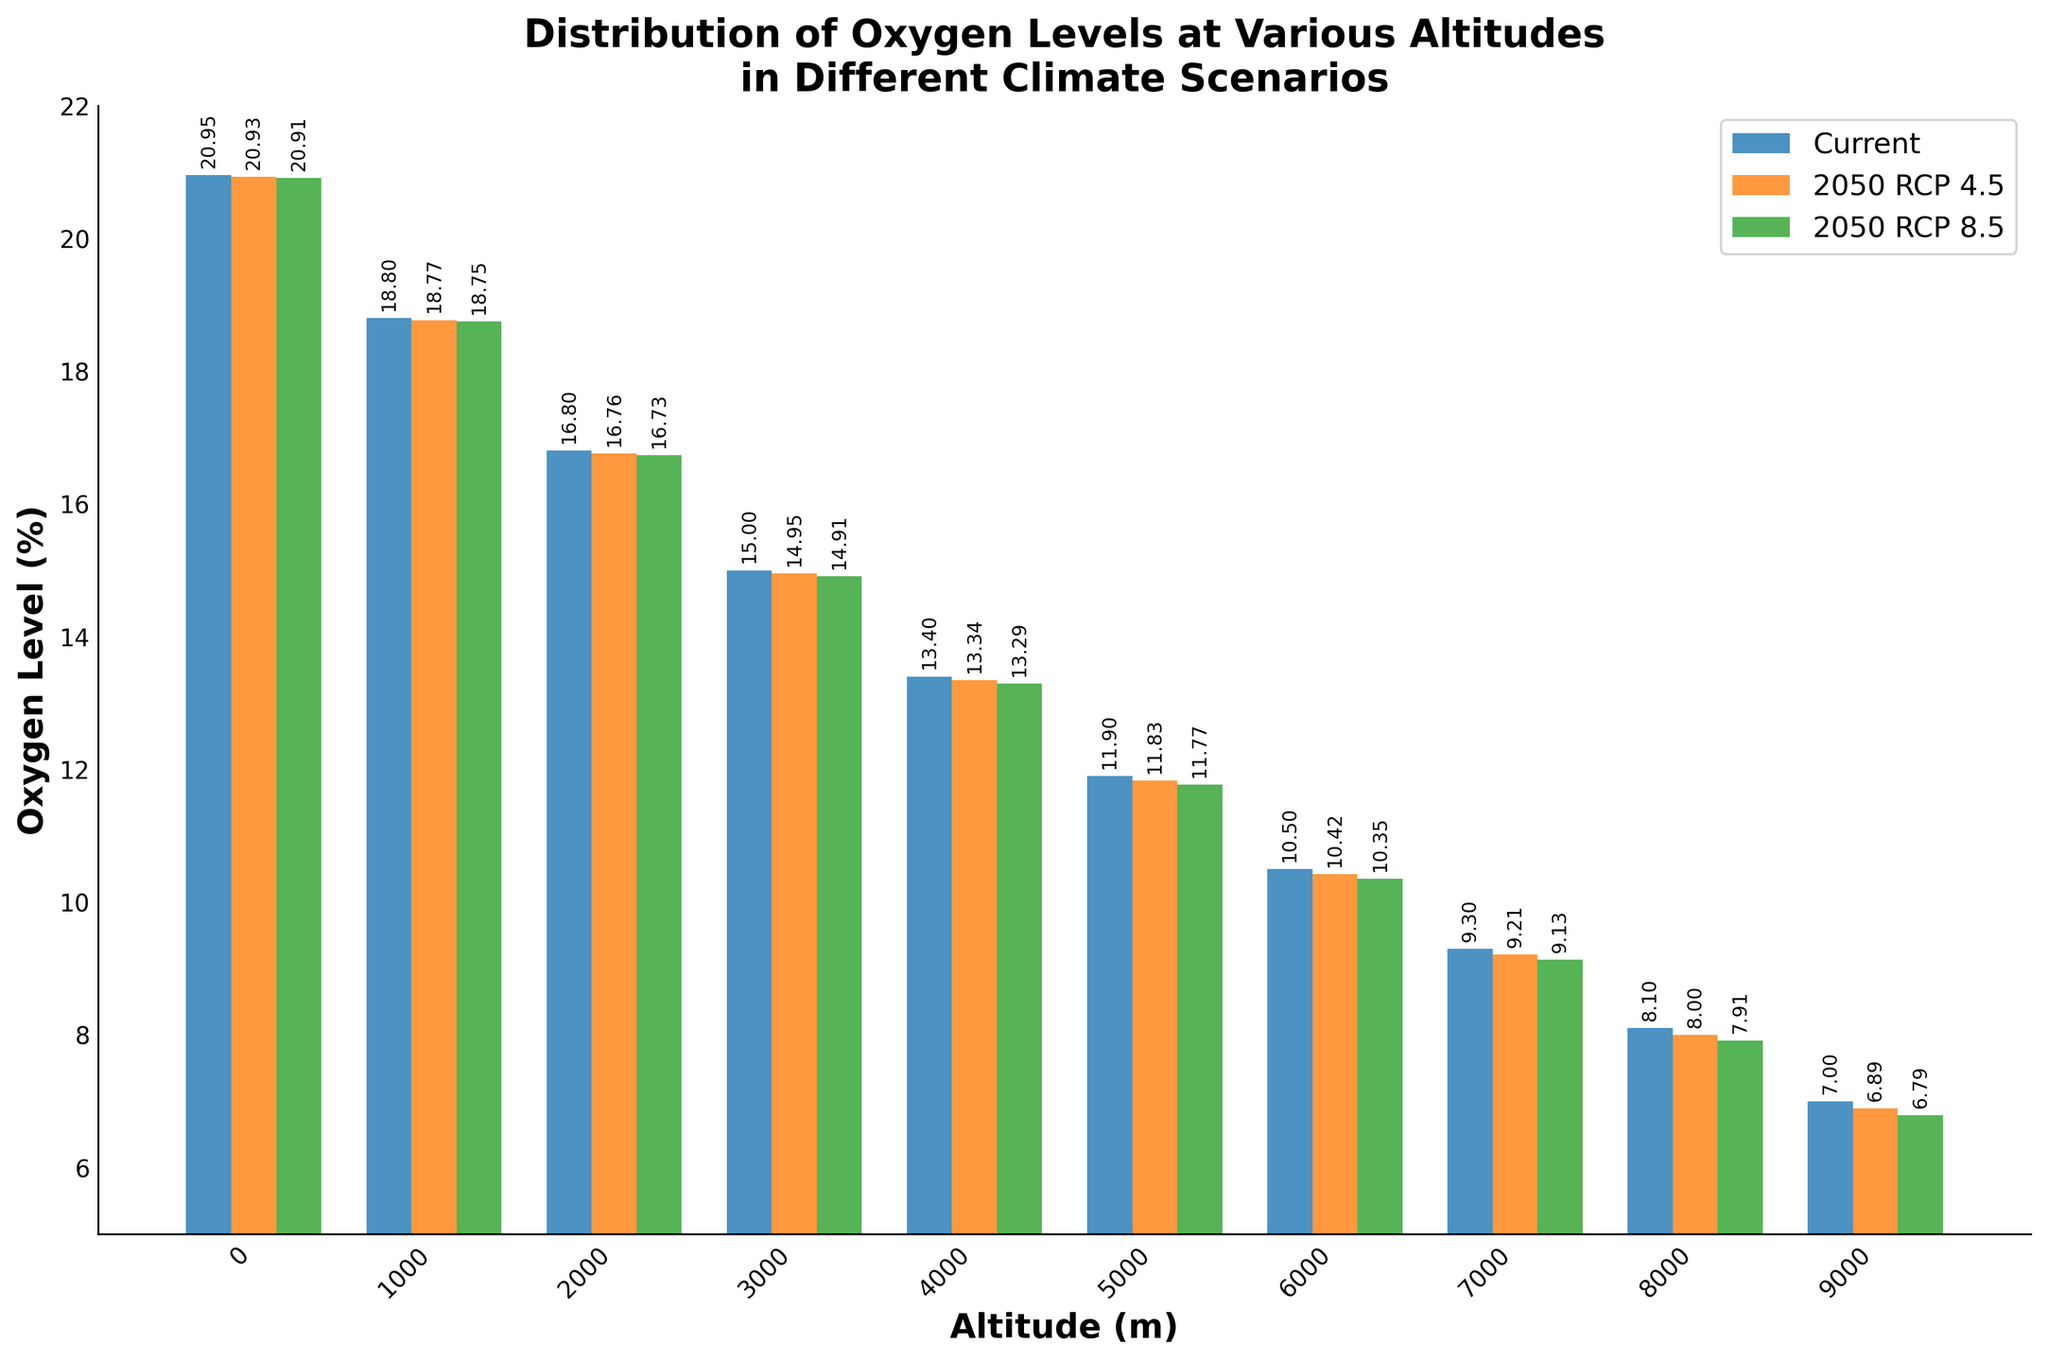What is the oxygen level at 2000 meters altitude in the current scenario? Locate the bar corresponding to 2000 meters (fourth bar in each group). The height of the blue bar representing the current scenario reads 16.8%.
Answer: 16.8% Which altitude shows the largest decrease in oxygen levels from the current scenario to the 2050 RCP 8.5 scenario? Follow each group of three bars from 0 to 9000 meters and note the difference between the height of the blue and green bars. The largest decrease is observed at 9000 meters, where the oxygen level decreases from 7.0% to 6.79%, a difference of 0.21%.
Answer: 9000 meters Comparing all altitudes, which altitude has the smallest oxygen level in the 2050 RCP 4.5 scenario? Examine the heights of the orange bars (2050 RCP 4.5 scenario) for each altitude. The smallest oxygen level is at 9000 meters, reading 6.89%.
Answer: 9000 meters Considering all scenarios and altitudes, what is the highest oxygen level recorded, and at which altitude? Observe all the bars and note the highest bar. The tallest bar is the blue one in the current scenario at 0 meters altitude with an oxygen level of 20.95%.
Answer: 20.95%, 0 meters What is the cumulative reduction in oxygen level from the current scenario to the 2050 RCP 4.5 scenario across all altitudes? Calculate the difference between current and 2050 RCP 4.5 oxygen levels for each altitude, sum these differences: (20.95-20.93) + (18.8-18.77) + (16.8-16.76) + (15.0-14.95) + (13.4-13.34) + (11.9-11.83) + (10.5-10.42) + (9.3-9.21) + (8.1-8.00) + (7.0-6.89). This equals 2.07%.
Answer: 2.07% What is the average oxygen level across all altitudes in the 2050 RCP 8.5 scenario? Sum the oxygen levels for 2050 RCP 8.5 across all altitudes and divide by the number of data points: (20.91 + 18.75 + 16.73 + 14.91 + 13.29 + 11.77 + 10.35 + 9.13 + 7.91 + 6.79) / 10, which equals 13.45%.
Answer: 13.45% Which altitude shows the smallest difference in oxygen levels between the 2050 RCP 4.5 and 2050 RCP 8.5 scenarios? Determine the differences for each altitude and identify the smallest: (20.93-20.91) + (18.77-18.75) + (16.76-16.73) + (14.95-14.91) + (13.34-13.29) + (11.83-11.77) + (10.42-10.35) + (9.21-9.13) + (8.00-7.91) + (6.89-6.79). The smallest difference is 0.02% at 0 meters.
Answer: 0 meters 